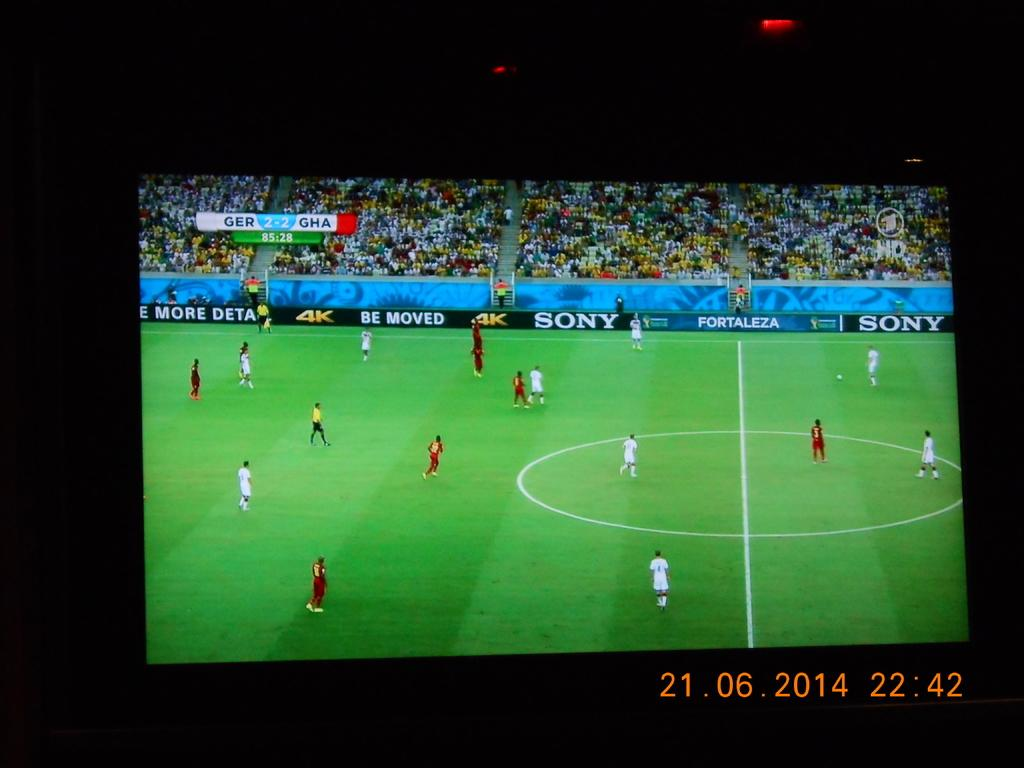Provide a one-sentence caption for the provided image. Germany and Ghana playing a soccer match with a time stamp on it. 